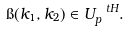<formula> <loc_0><loc_0><loc_500><loc_500>\i ( k _ { 1 } , k _ { 2 } ) \in U _ { p } ^ { \ t H } .</formula> 